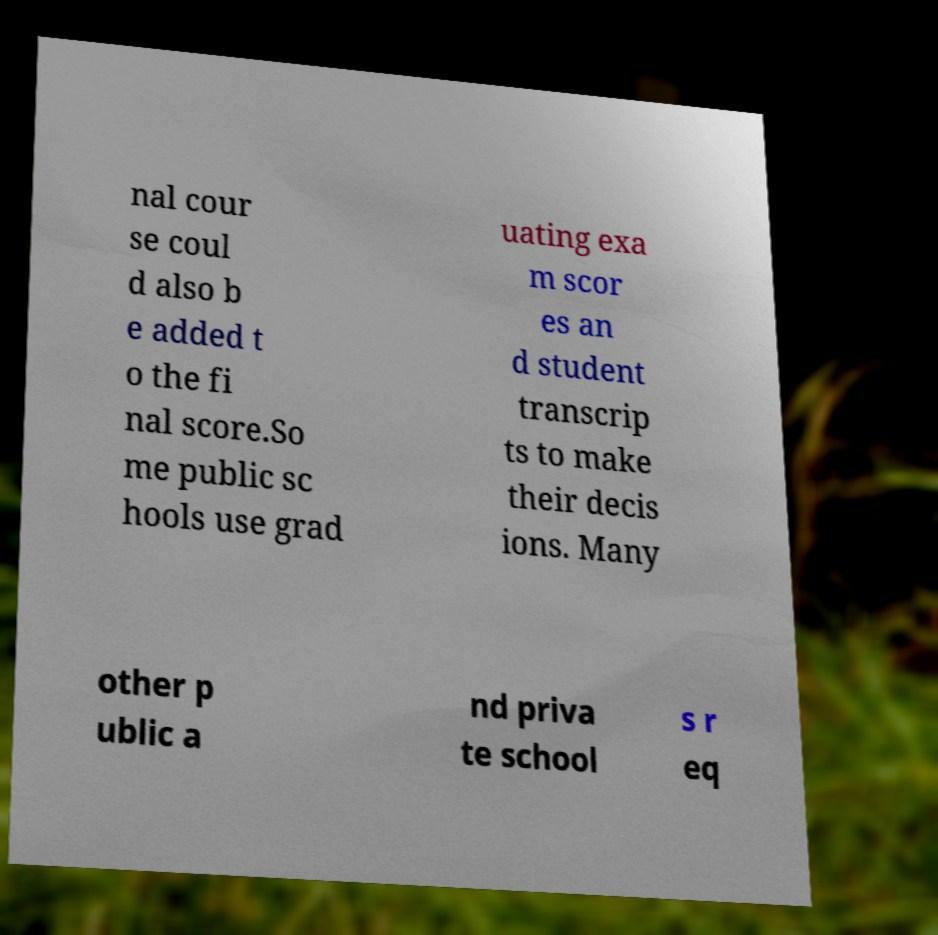I need the written content from this picture converted into text. Can you do that? nal cour se coul d also b e added t o the fi nal score.So me public sc hools use grad uating exa m scor es an d student transcrip ts to make their decis ions. Many other p ublic a nd priva te school s r eq 